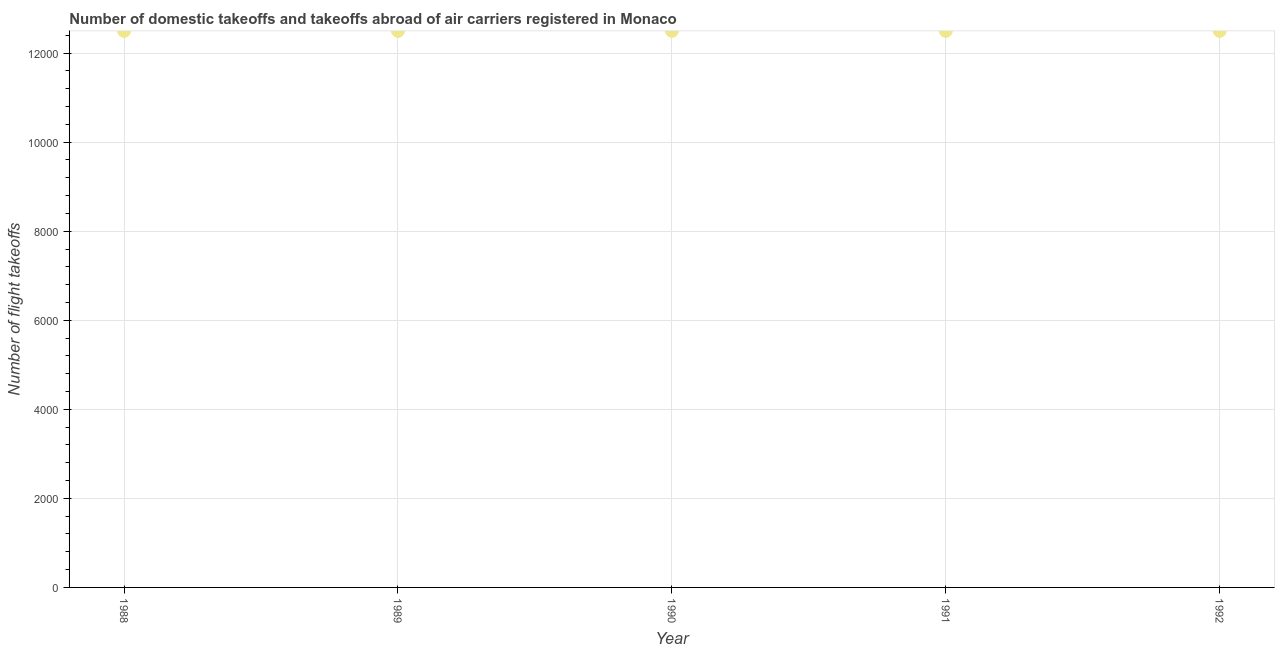What is the number of flight takeoffs in 1991?
Keep it short and to the point. 1.25e+04. Across all years, what is the maximum number of flight takeoffs?
Provide a short and direct response. 1.25e+04. Across all years, what is the minimum number of flight takeoffs?
Your response must be concise. 1.25e+04. In which year was the number of flight takeoffs minimum?
Keep it short and to the point. 1988. What is the sum of the number of flight takeoffs?
Your answer should be compact. 6.25e+04. What is the average number of flight takeoffs per year?
Your answer should be very brief. 1.25e+04. What is the median number of flight takeoffs?
Keep it short and to the point. 1.25e+04. Is the difference between the number of flight takeoffs in 1988 and 1990 greater than the difference between any two years?
Keep it short and to the point. Yes. In how many years, is the number of flight takeoffs greater than the average number of flight takeoffs taken over all years?
Provide a succinct answer. 0. Are the values on the major ticks of Y-axis written in scientific E-notation?
Ensure brevity in your answer.  No. What is the title of the graph?
Offer a very short reply. Number of domestic takeoffs and takeoffs abroad of air carriers registered in Monaco. What is the label or title of the Y-axis?
Offer a terse response. Number of flight takeoffs. What is the Number of flight takeoffs in 1988?
Provide a succinct answer. 1.25e+04. What is the Number of flight takeoffs in 1989?
Provide a short and direct response. 1.25e+04. What is the Number of flight takeoffs in 1990?
Offer a very short reply. 1.25e+04. What is the Number of flight takeoffs in 1991?
Offer a very short reply. 1.25e+04. What is the Number of flight takeoffs in 1992?
Your answer should be very brief. 1.25e+04. What is the difference between the Number of flight takeoffs in 1988 and 1990?
Provide a short and direct response. 0. What is the difference between the Number of flight takeoffs in 1989 and 1991?
Your answer should be compact. 0. What is the difference between the Number of flight takeoffs in 1990 and 1991?
Your response must be concise. 0. What is the difference between the Number of flight takeoffs in 1990 and 1992?
Ensure brevity in your answer.  0. What is the ratio of the Number of flight takeoffs in 1988 to that in 1991?
Provide a short and direct response. 1. What is the ratio of the Number of flight takeoffs in 1989 to that in 1990?
Offer a very short reply. 1. What is the ratio of the Number of flight takeoffs in 1989 to that in 1992?
Offer a terse response. 1. What is the ratio of the Number of flight takeoffs in 1990 to that in 1991?
Provide a short and direct response. 1. What is the ratio of the Number of flight takeoffs in 1990 to that in 1992?
Give a very brief answer. 1. 